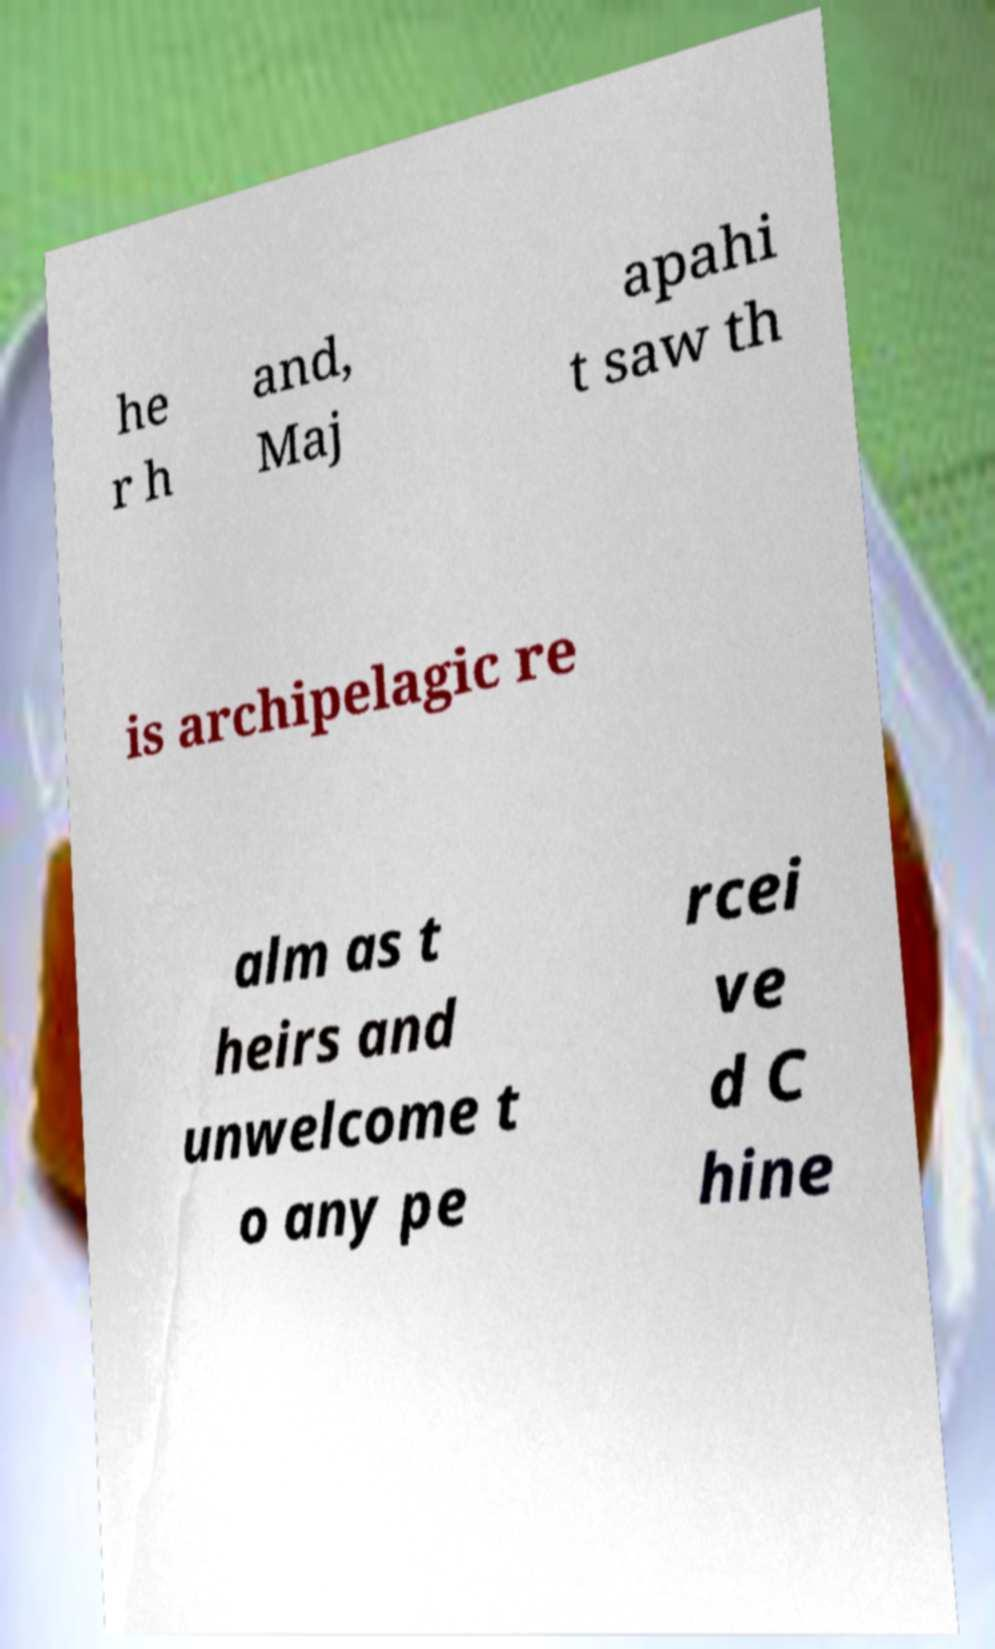I need the written content from this picture converted into text. Can you do that? he r h and, Maj apahi t saw th is archipelagic re alm as t heirs and unwelcome t o any pe rcei ve d C hine 